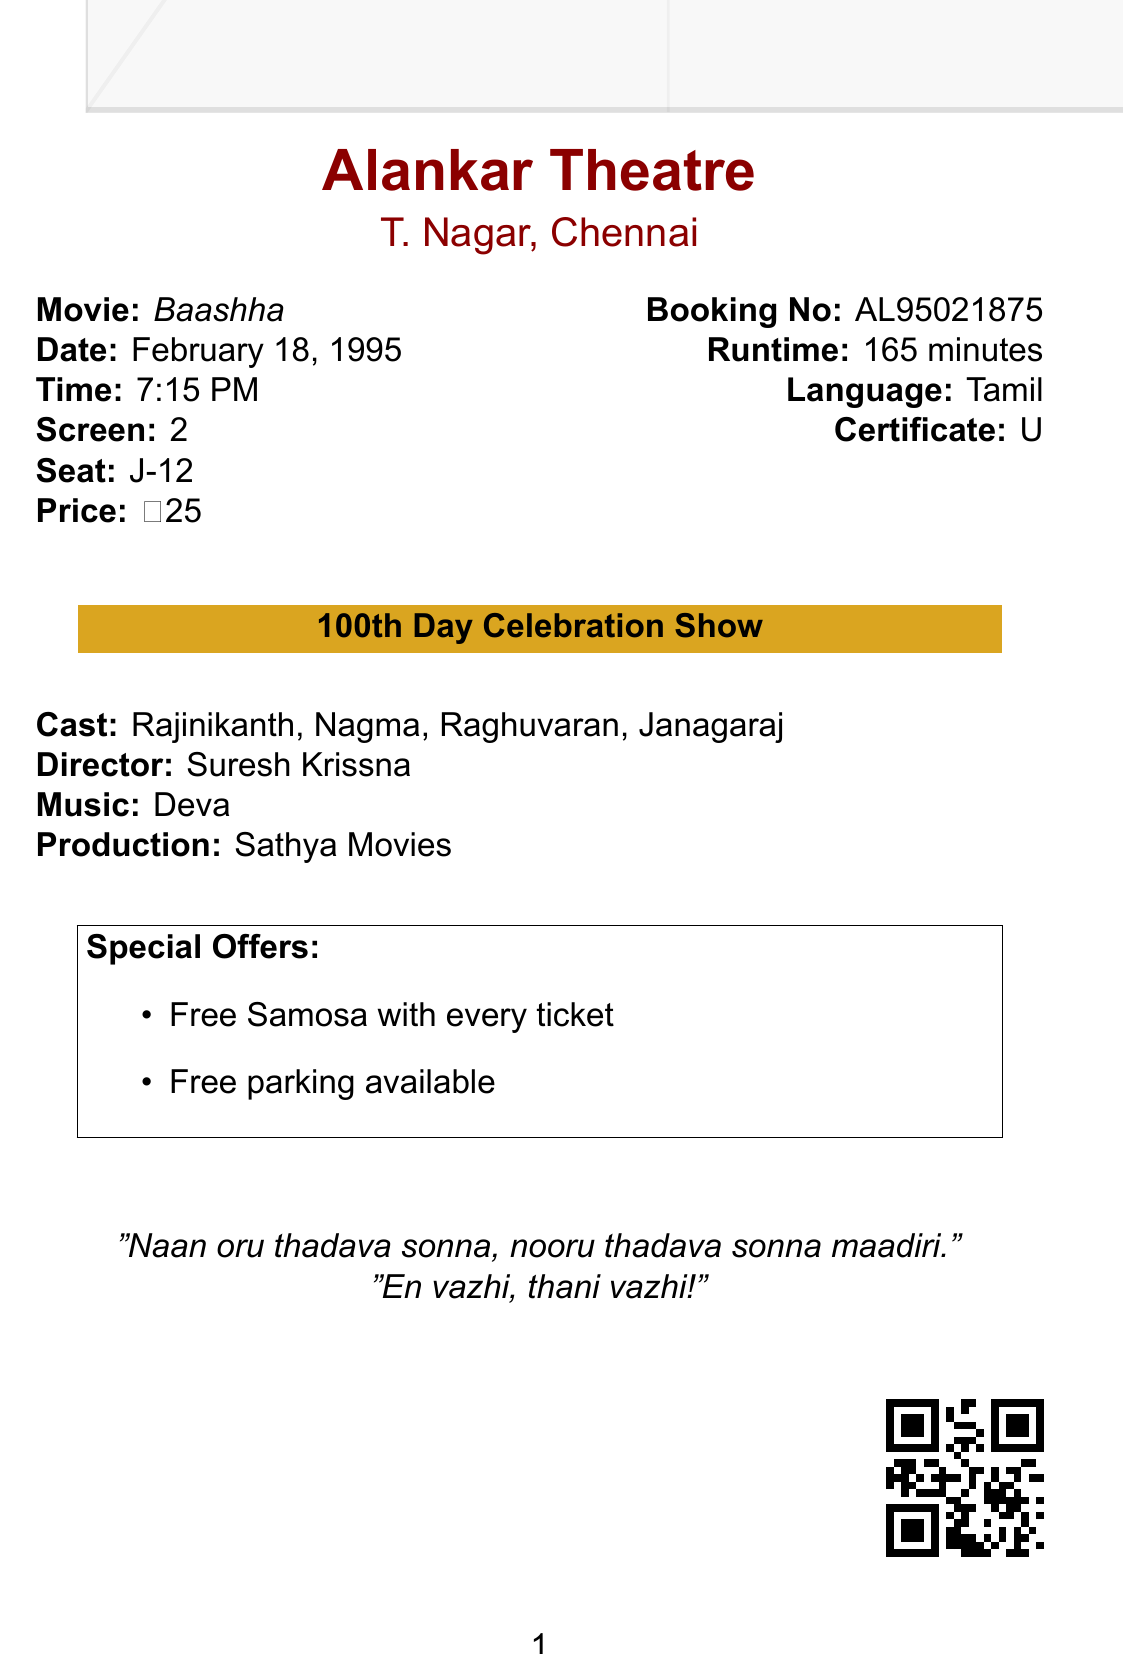What is the movie title? The movie title is clearly mentioned on the receipt.
Answer: Baashha Who is the lead actor? The lead actor is listed in the cast section of the document.
Answer: Rajinikanth What is the show date? The show date is specified in the document.
Answer: February 18, 1995 What is the ticket price? The ticket price is explicitly stated in the document under the pricing section.
Answer: ₹25 What special offer is mentioned? The special offers are detailed in a specific section of the document.
Answer: Free Samosa with every ticket How long is the movie's runtime? The total runtime is provided in the document, indicating the movie's length.
Answer: 165 minutes What is the booking number? The booking number is stated in a dedicated section on the receipt.
Answer: AL95021875 Which theater is screening the movie? The theater name and location are included at the top of the document.
Answer: Alankar Theatre Who directed the movie? The director's name is listed in the cast and crew information.
Answer: Suresh Krissna What is the special note regarding the show? The special note is highlighted as part of the show details.
Answer: 100th Day Celebration Show 